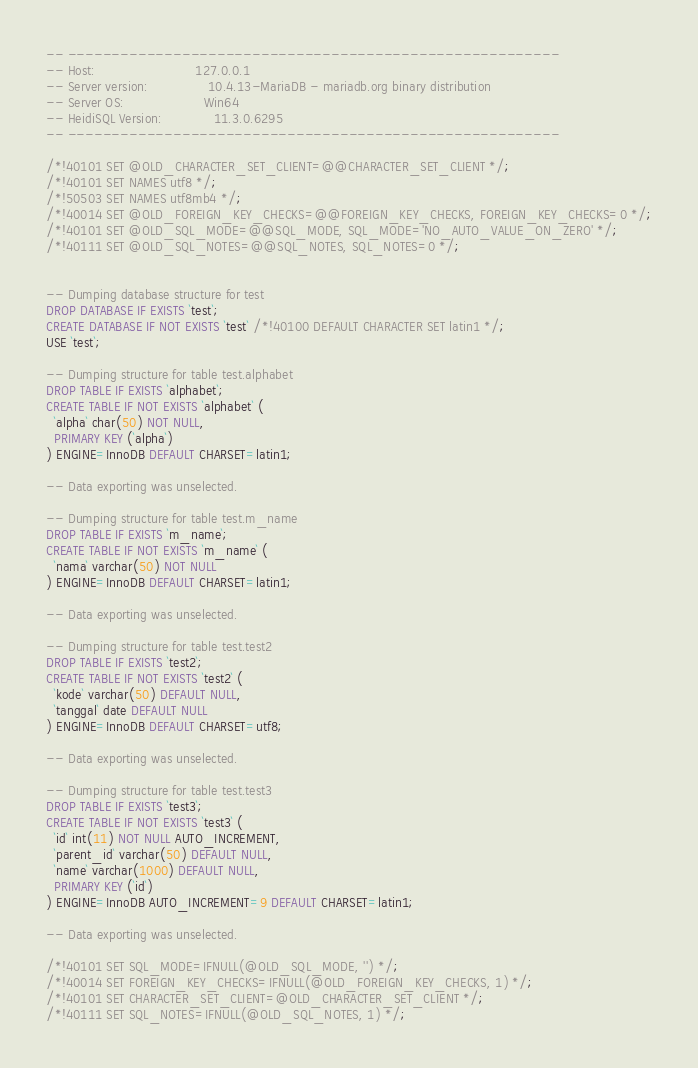Convert code to text. <code><loc_0><loc_0><loc_500><loc_500><_SQL_>-- --------------------------------------------------------
-- Host:                         127.0.0.1
-- Server version:               10.4.13-MariaDB - mariadb.org binary distribution
-- Server OS:                    Win64
-- HeidiSQL Version:             11.3.0.6295
-- --------------------------------------------------------

/*!40101 SET @OLD_CHARACTER_SET_CLIENT=@@CHARACTER_SET_CLIENT */;
/*!40101 SET NAMES utf8 */;
/*!50503 SET NAMES utf8mb4 */;
/*!40014 SET @OLD_FOREIGN_KEY_CHECKS=@@FOREIGN_KEY_CHECKS, FOREIGN_KEY_CHECKS=0 */;
/*!40101 SET @OLD_SQL_MODE=@@SQL_MODE, SQL_MODE='NO_AUTO_VALUE_ON_ZERO' */;
/*!40111 SET @OLD_SQL_NOTES=@@SQL_NOTES, SQL_NOTES=0 */;


-- Dumping database structure for test
DROP DATABASE IF EXISTS `test`;
CREATE DATABASE IF NOT EXISTS `test` /*!40100 DEFAULT CHARACTER SET latin1 */;
USE `test`;

-- Dumping structure for table test.alphabet
DROP TABLE IF EXISTS `alphabet`;
CREATE TABLE IF NOT EXISTS `alphabet` (
  `alpha` char(50) NOT NULL,
  PRIMARY KEY (`alpha`)
) ENGINE=InnoDB DEFAULT CHARSET=latin1;

-- Data exporting was unselected.

-- Dumping structure for table test.m_name
DROP TABLE IF EXISTS `m_name`;
CREATE TABLE IF NOT EXISTS `m_name` (
  `nama` varchar(50) NOT NULL
) ENGINE=InnoDB DEFAULT CHARSET=latin1;

-- Data exporting was unselected.

-- Dumping structure for table test.test2
DROP TABLE IF EXISTS `test2`;
CREATE TABLE IF NOT EXISTS `test2` (
  `kode` varchar(50) DEFAULT NULL,
  `tanggal` date DEFAULT NULL
) ENGINE=InnoDB DEFAULT CHARSET=utf8;

-- Data exporting was unselected.

-- Dumping structure for table test.test3
DROP TABLE IF EXISTS `test3`;
CREATE TABLE IF NOT EXISTS `test3` (
  `id` int(11) NOT NULL AUTO_INCREMENT,
  `parent_id` varchar(50) DEFAULT NULL,
  `name` varchar(1000) DEFAULT NULL,
  PRIMARY KEY (`id`)
) ENGINE=InnoDB AUTO_INCREMENT=9 DEFAULT CHARSET=latin1;

-- Data exporting was unselected.

/*!40101 SET SQL_MODE=IFNULL(@OLD_SQL_MODE, '') */;
/*!40014 SET FOREIGN_KEY_CHECKS=IFNULL(@OLD_FOREIGN_KEY_CHECKS, 1) */;
/*!40101 SET CHARACTER_SET_CLIENT=@OLD_CHARACTER_SET_CLIENT */;
/*!40111 SET SQL_NOTES=IFNULL(@OLD_SQL_NOTES, 1) */;
</code> 